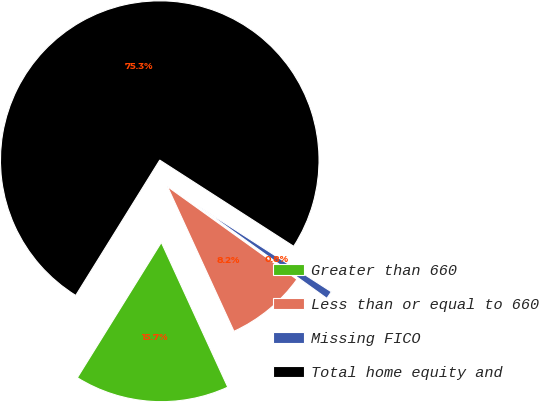Convert chart. <chart><loc_0><loc_0><loc_500><loc_500><pie_chart><fcel>Greater than 660<fcel>Less than or equal to 660<fcel>Missing FICO<fcel>Total home equity and<nl><fcel>15.69%<fcel>8.25%<fcel>0.8%<fcel>75.26%<nl></chart> 